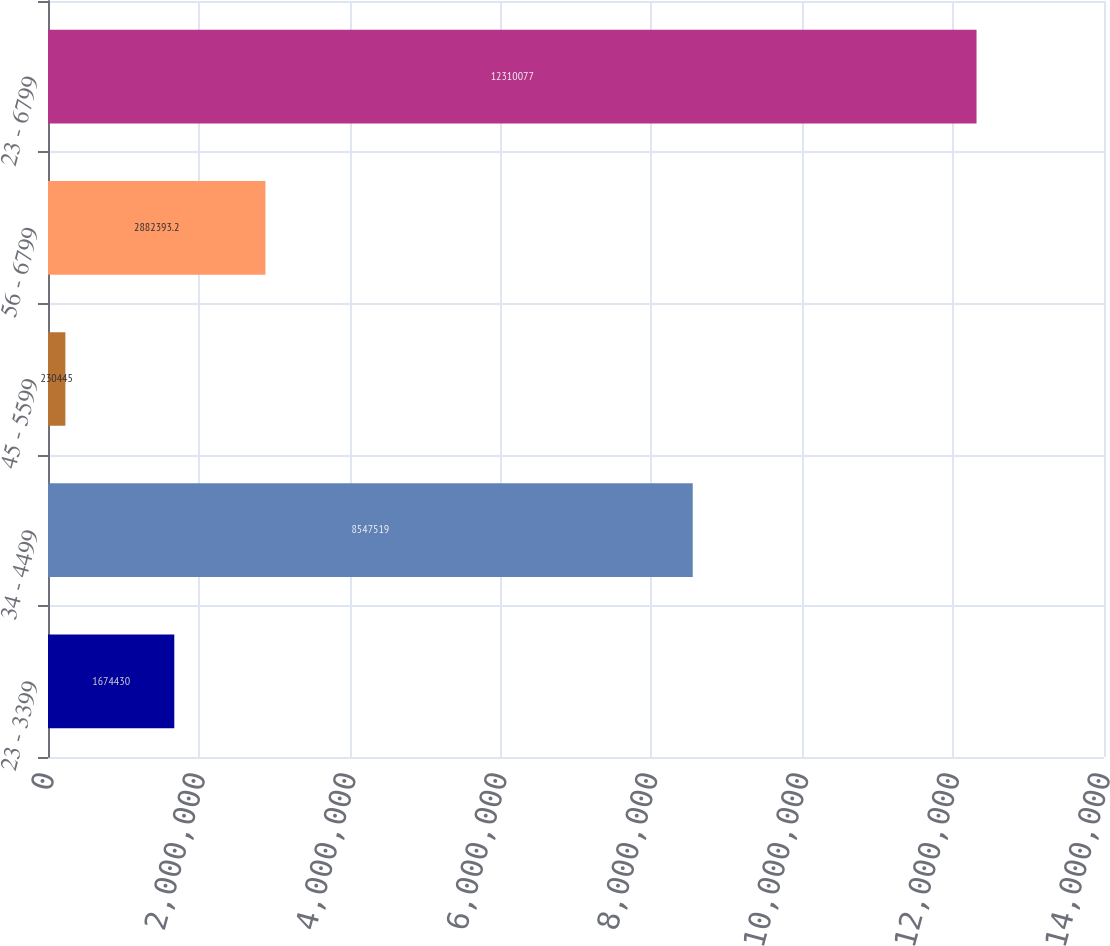<chart> <loc_0><loc_0><loc_500><loc_500><bar_chart><fcel>23 - 3399<fcel>34 - 4499<fcel>45 - 5599<fcel>56 - 6799<fcel>23 - 6799<nl><fcel>1.67443e+06<fcel>8.54752e+06<fcel>230445<fcel>2.88239e+06<fcel>1.23101e+07<nl></chart> 